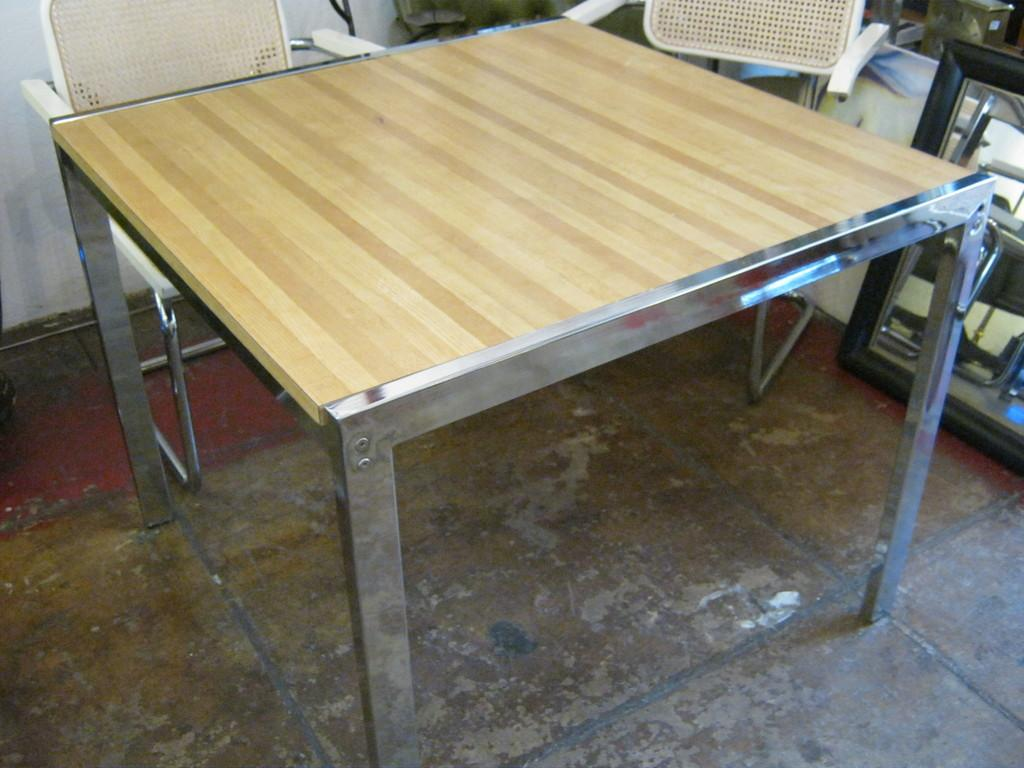What piece of furniture is present in the image? There is a table in the image. What can be seen in front of the table? There are two chairs in front of the table. Are there any objects placed on the floor in the image? Yes, there are objects placed on the floor in the top right side of the image. What type of waves can be seen in the image? There are no waves present in the image. 